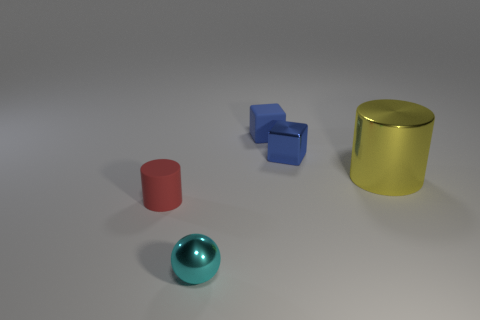Add 4 large metallic cubes. How many objects exist? 9 Subtract all spheres. How many objects are left? 4 Subtract all cyan metallic objects. Subtract all blue objects. How many objects are left? 2 Add 1 blocks. How many blocks are left? 3 Add 4 yellow cylinders. How many yellow cylinders exist? 5 Subtract 0 gray cubes. How many objects are left? 5 